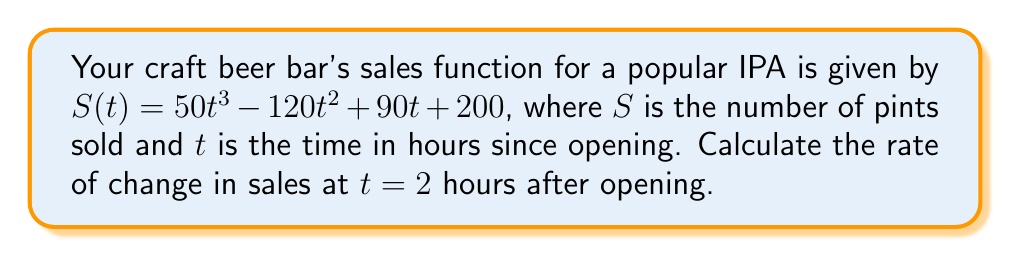Could you help me with this problem? To find the rate of change in sales at a specific time, we need to calculate the derivative of the sales function and evaluate it at the given time.

Step 1: Find the derivative of $S(t)$.
$$\frac{dS}{dt} = S'(t) = 150t^2 - 240t + 90$$

Step 2: Evaluate the derivative at $t = 2$ hours.
$$S'(2) = 150(2)^2 - 240(2) + 90$$
$$S'(2) = 150(4) - 480 + 90$$
$$S'(2) = 600 - 480 + 90$$
$$S'(2) = 210$$

The rate of change in sales at $t = 2$ hours after opening is 210 pints per hour.
Answer: 210 pints/hour 